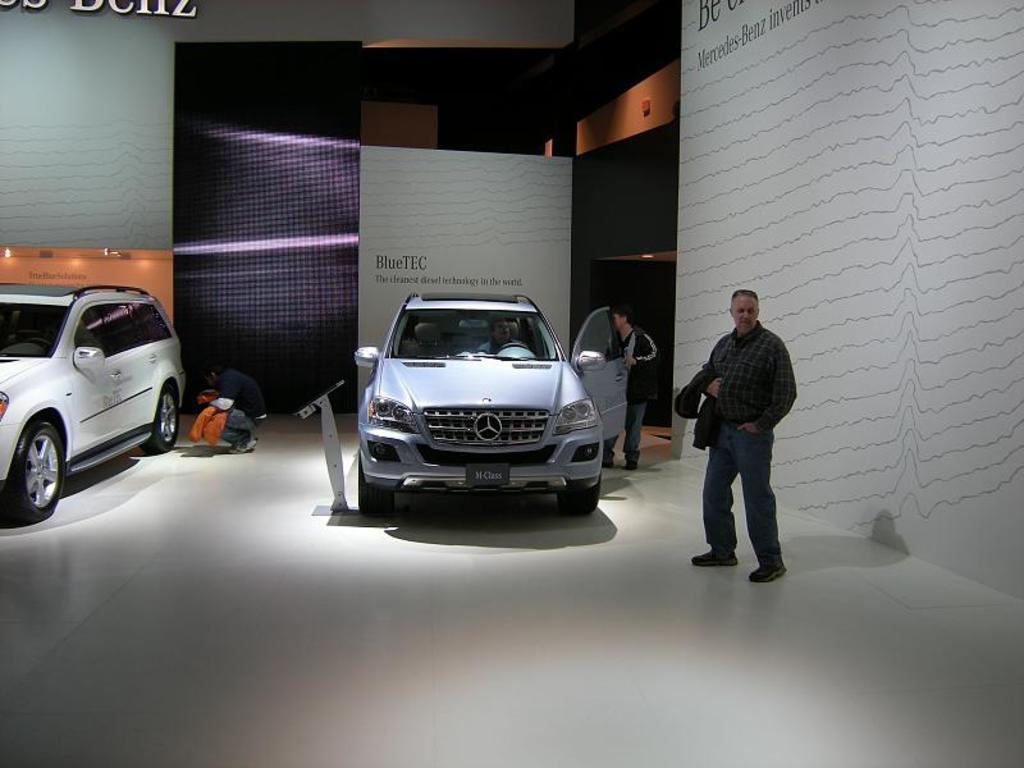What is placed on the floor in the image? There is a car on the floor in the image. Who is inside the car? A person is sitting in the car. Are there any other people in the image? Yes, there is a person standing in the image. What can be seen in the background of the image? There is a wall in the image. Is there any source of light visible? Yes, there is a light in the image. What type of drain can be seen in the image? There is no drain present in the image. What is the condition of the person's teeth in the image? There is no information about the person's teeth in the image. 